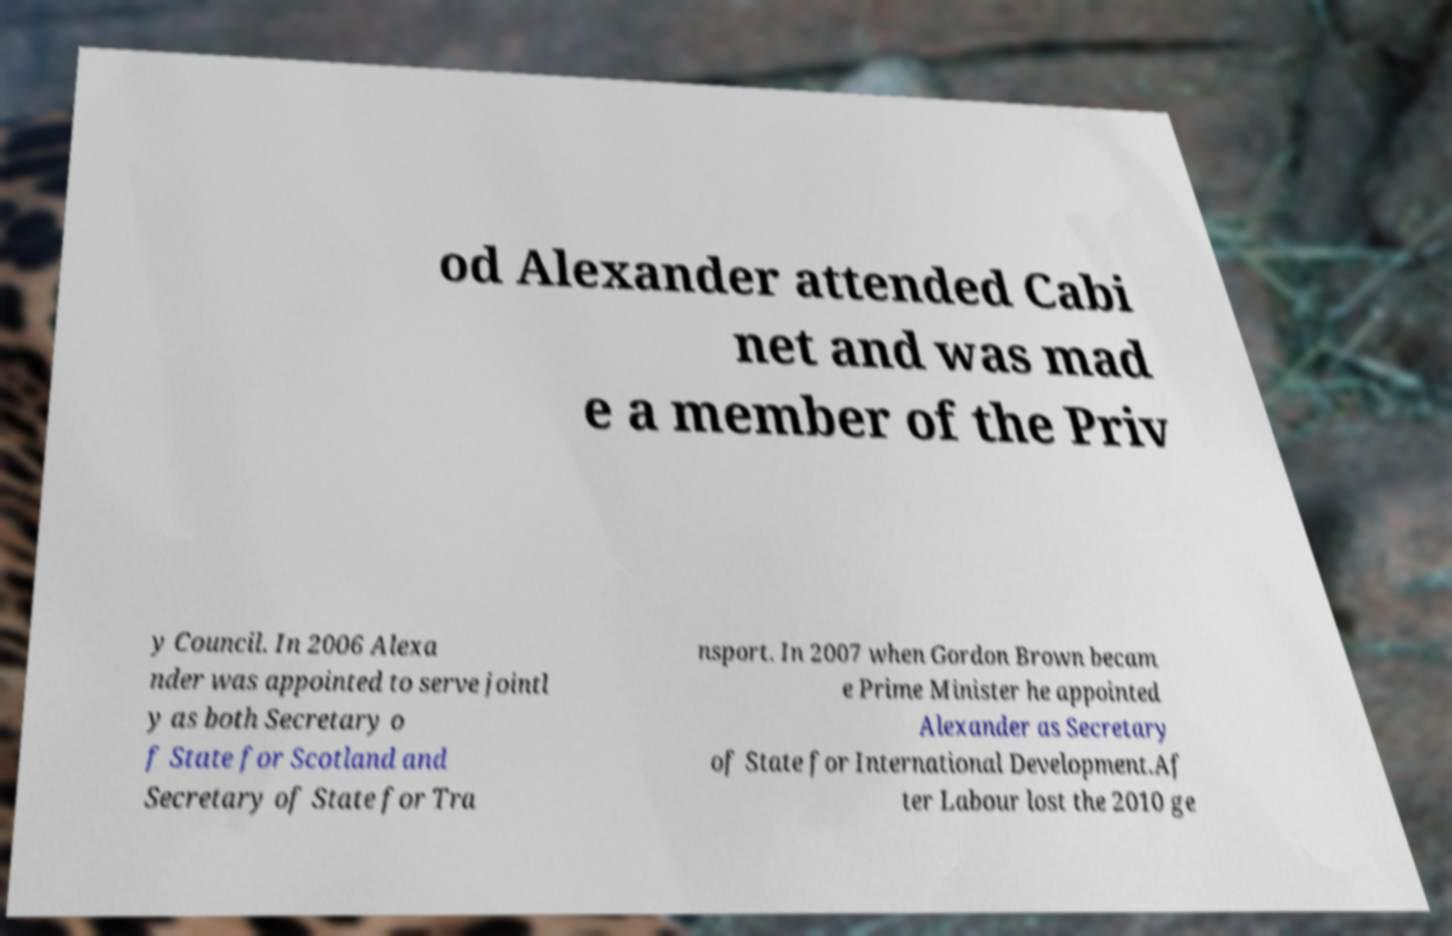Can you read and provide the text displayed in the image?This photo seems to have some interesting text. Can you extract and type it out for me? od Alexander attended Cabi net and was mad e a member of the Priv y Council. In 2006 Alexa nder was appointed to serve jointl y as both Secretary o f State for Scotland and Secretary of State for Tra nsport. In 2007 when Gordon Brown becam e Prime Minister he appointed Alexander as Secretary of State for International Development.Af ter Labour lost the 2010 ge 